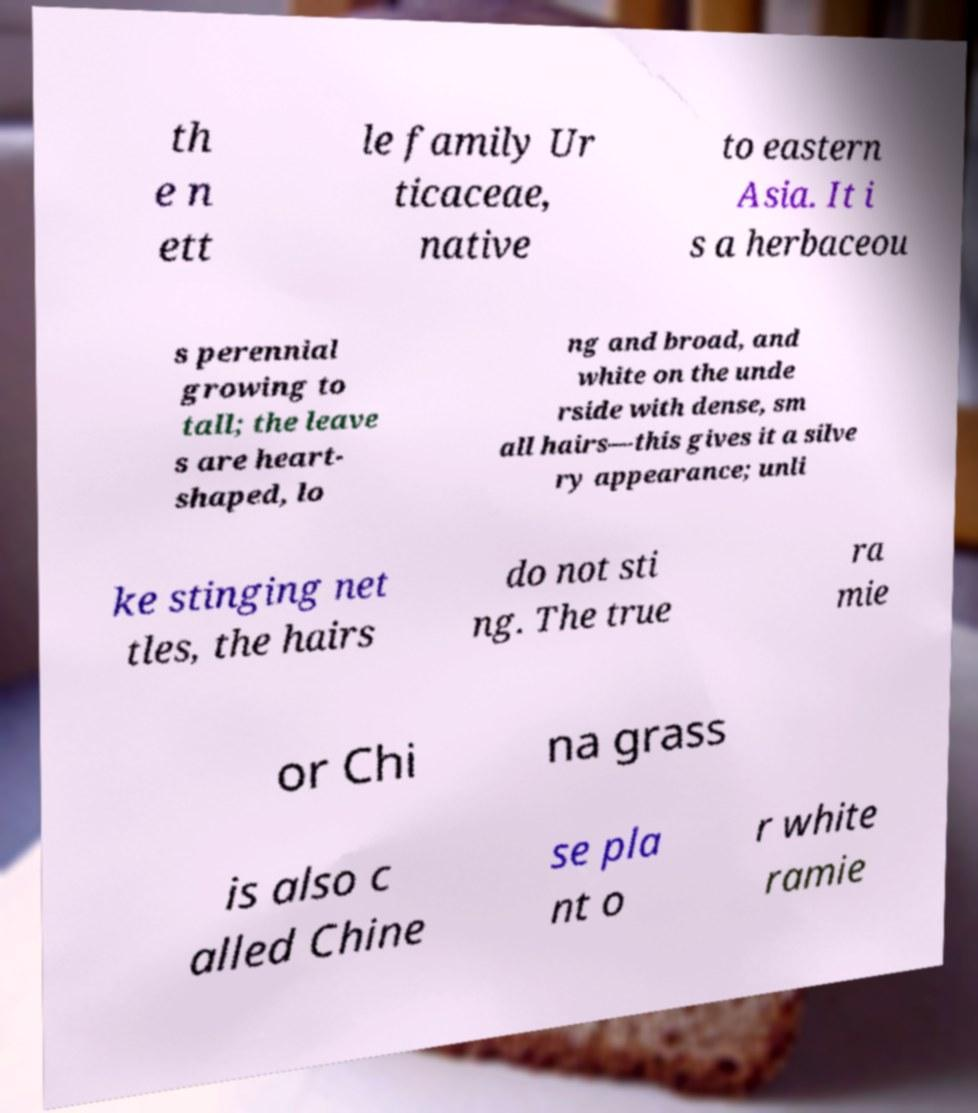Can you read and provide the text displayed in the image?This photo seems to have some interesting text. Can you extract and type it out for me? th e n ett le family Ur ticaceae, native to eastern Asia. It i s a herbaceou s perennial growing to tall; the leave s are heart- shaped, lo ng and broad, and white on the unde rside with dense, sm all hairs—this gives it a silve ry appearance; unli ke stinging net tles, the hairs do not sti ng. The true ra mie or Chi na grass is also c alled Chine se pla nt o r white ramie 